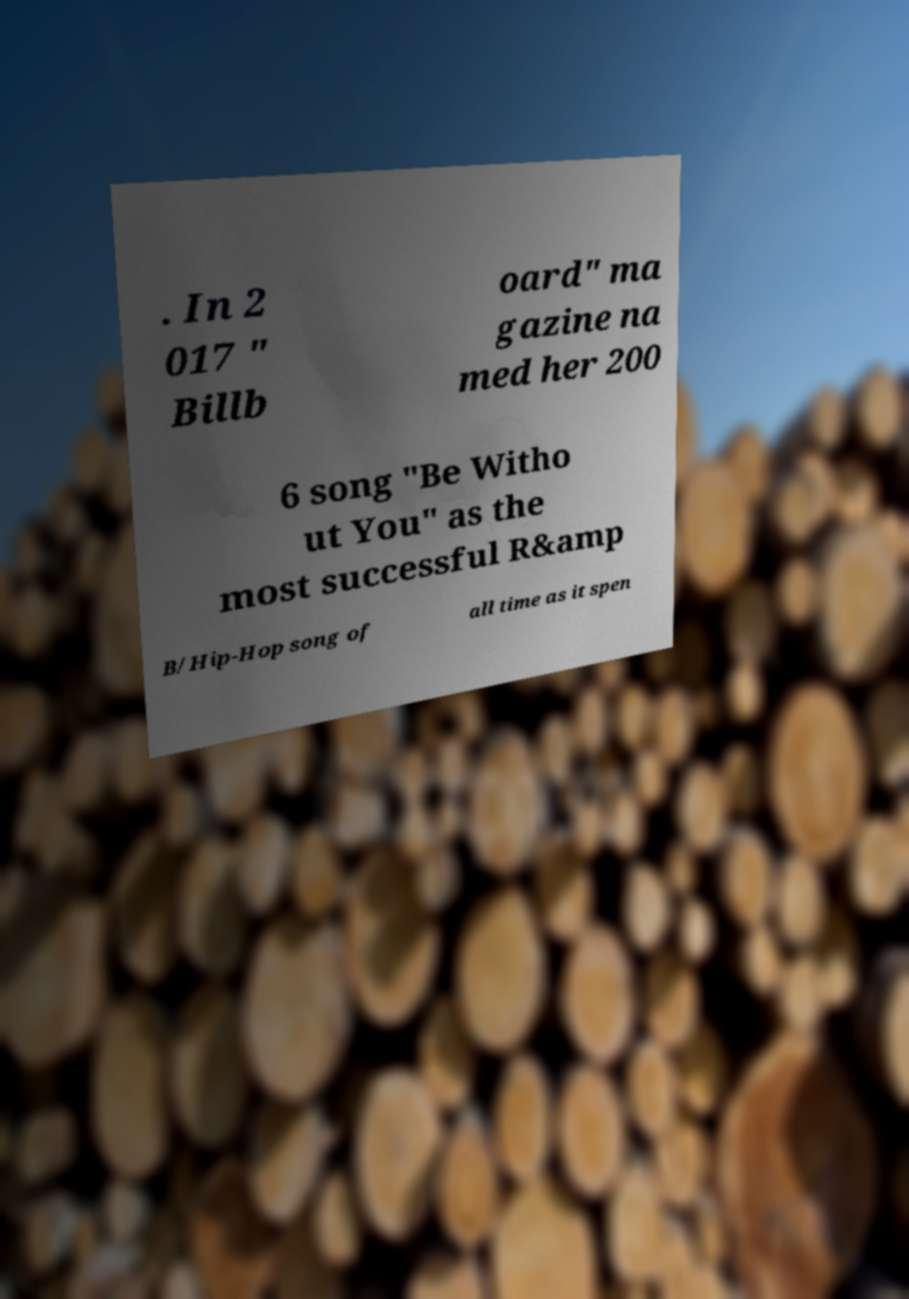Can you read and provide the text displayed in the image?This photo seems to have some interesting text. Can you extract and type it out for me? . In 2 017 " Billb oard" ma gazine na med her 200 6 song "Be Witho ut You" as the most successful R&amp B/Hip-Hop song of all time as it spen 